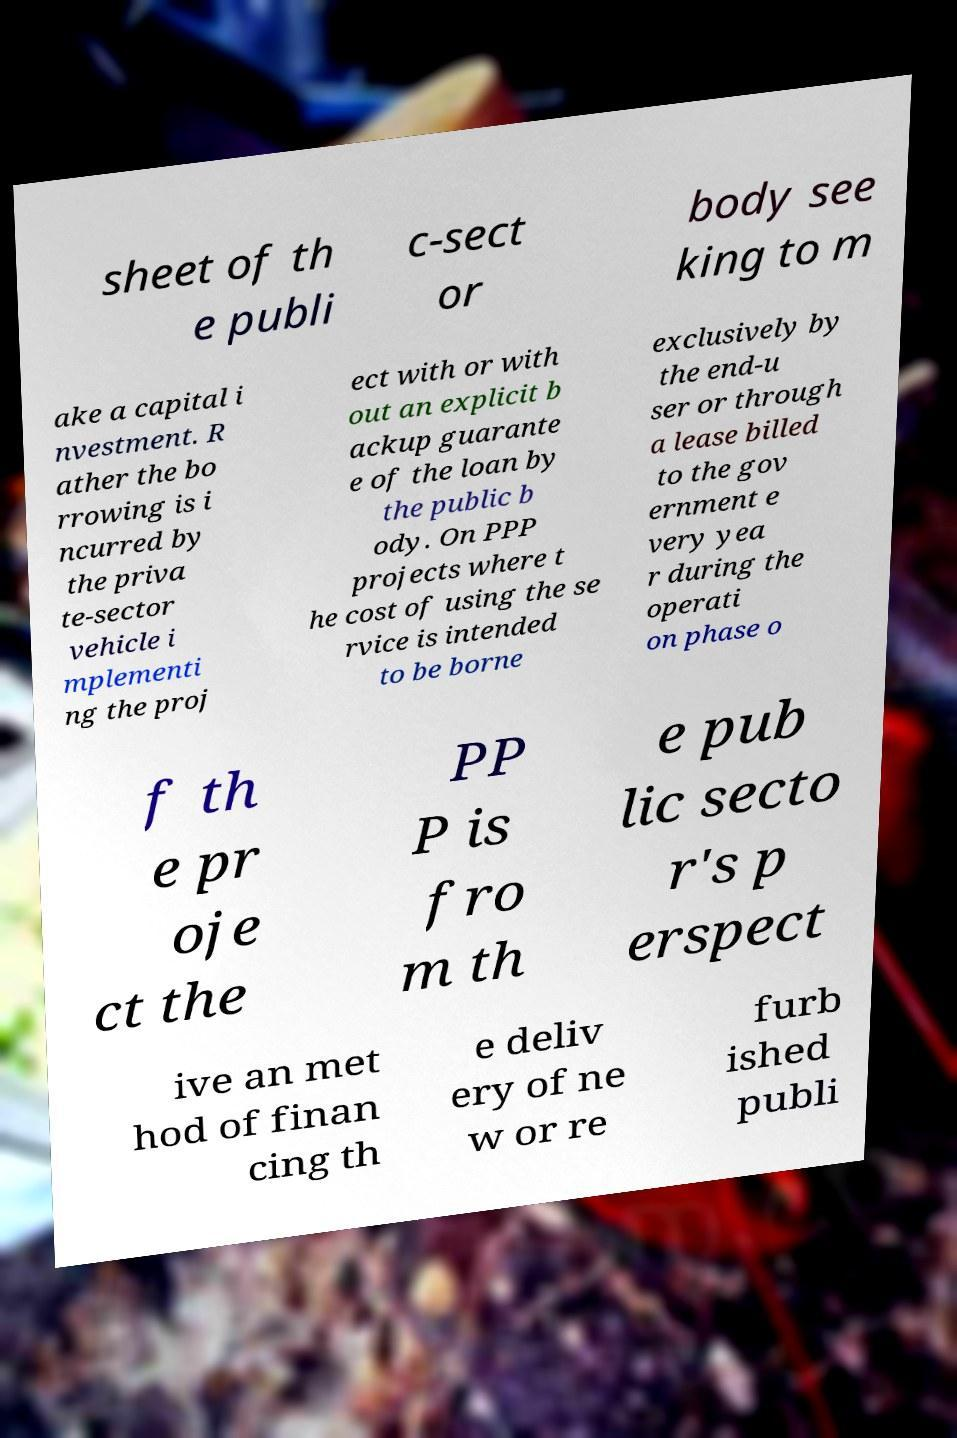I need the written content from this picture converted into text. Can you do that? sheet of th e publi c-sect or body see king to m ake a capital i nvestment. R ather the bo rrowing is i ncurred by the priva te-sector vehicle i mplementi ng the proj ect with or with out an explicit b ackup guarante e of the loan by the public b ody. On PPP projects where t he cost of using the se rvice is intended to be borne exclusively by the end-u ser or through a lease billed to the gov ernment e very yea r during the operati on phase o f th e pr oje ct the PP P is fro m th e pub lic secto r's p erspect ive an met hod of finan cing th e deliv ery of ne w or re furb ished publi 